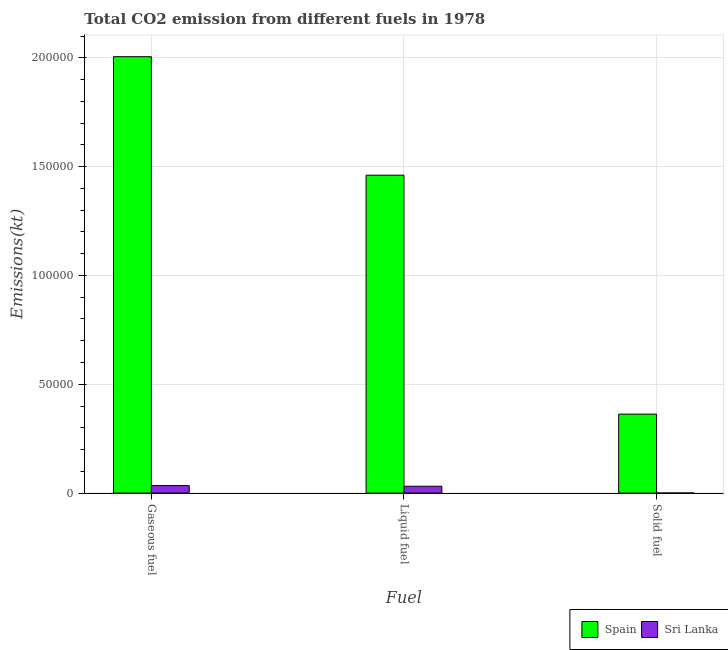Are the number of bars per tick equal to the number of legend labels?
Offer a very short reply. Yes. Are the number of bars on each tick of the X-axis equal?
Provide a succinct answer. Yes. How many bars are there on the 3rd tick from the left?
Provide a short and direct response. 2. What is the label of the 2nd group of bars from the left?
Your response must be concise. Liquid fuel. What is the amount of co2 emissions from solid fuel in Spain?
Offer a very short reply. 3.63e+04. Across all countries, what is the maximum amount of co2 emissions from gaseous fuel?
Offer a very short reply. 2.00e+05. Across all countries, what is the minimum amount of co2 emissions from solid fuel?
Keep it short and to the point. 29.34. In which country was the amount of co2 emissions from solid fuel minimum?
Your response must be concise. Sri Lanka. What is the total amount of co2 emissions from solid fuel in the graph?
Ensure brevity in your answer.  3.63e+04. What is the difference between the amount of co2 emissions from solid fuel in Sri Lanka and that in Spain?
Your response must be concise. -3.62e+04. What is the difference between the amount of co2 emissions from solid fuel in Spain and the amount of co2 emissions from gaseous fuel in Sri Lanka?
Keep it short and to the point. 3.28e+04. What is the average amount of co2 emissions from solid fuel per country?
Your response must be concise. 1.81e+04. What is the difference between the amount of co2 emissions from solid fuel and amount of co2 emissions from liquid fuel in Spain?
Make the answer very short. -1.10e+05. In how many countries, is the amount of co2 emissions from solid fuel greater than 40000 kt?
Keep it short and to the point. 0. What is the ratio of the amount of co2 emissions from liquid fuel in Sri Lanka to that in Spain?
Provide a short and direct response. 0.02. Is the amount of co2 emissions from gaseous fuel in Sri Lanka less than that in Spain?
Your answer should be compact. Yes. Is the difference between the amount of co2 emissions from solid fuel in Spain and Sri Lanka greater than the difference between the amount of co2 emissions from gaseous fuel in Spain and Sri Lanka?
Offer a very short reply. No. What is the difference between the highest and the second highest amount of co2 emissions from liquid fuel?
Offer a terse response. 1.43e+05. What is the difference between the highest and the lowest amount of co2 emissions from solid fuel?
Keep it short and to the point. 3.62e+04. In how many countries, is the amount of co2 emissions from solid fuel greater than the average amount of co2 emissions from solid fuel taken over all countries?
Your answer should be compact. 1. What does the 2nd bar from the left in Liquid fuel represents?
Keep it short and to the point. Sri Lanka. Is it the case that in every country, the sum of the amount of co2 emissions from gaseous fuel and amount of co2 emissions from liquid fuel is greater than the amount of co2 emissions from solid fuel?
Ensure brevity in your answer.  Yes. Does the graph contain any zero values?
Keep it short and to the point. No. How are the legend labels stacked?
Your answer should be very brief. Horizontal. What is the title of the graph?
Keep it short and to the point. Total CO2 emission from different fuels in 1978. Does "Sao Tome and Principe" appear as one of the legend labels in the graph?
Your answer should be very brief. No. What is the label or title of the X-axis?
Give a very brief answer. Fuel. What is the label or title of the Y-axis?
Provide a succinct answer. Emissions(kt). What is the Emissions(kt) of Spain in Gaseous fuel?
Your response must be concise. 2.00e+05. What is the Emissions(kt) of Sri Lanka in Gaseous fuel?
Keep it short and to the point. 3450.65. What is the Emissions(kt) in Spain in Liquid fuel?
Offer a very short reply. 1.46e+05. What is the Emissions(kt) of Sri Lanka in Liquid fuel?
Your answer should be compact. 3135.28. What is the Emissions(kt) of Spain in Solid fuel?
Offer a terse response. 3.63e+04. What is the Emissions(kt) in Sri Lanka in Solid fuel?
Your answer should be very brief. 29.34. Across all Fuel, what is the maximum Emissions(kt) in Spain?
Your answer should be compact. 2.00e+05. Across all Fuel, what is the maximum Emissions(kt) of Sri Lanka?
Ensure brevity in your answer.  3450.65. Across all Fuel, what is the minimum Emissions(kt) in Spain?
Make the answer very short. 3.63e+04. Across all Fuel, what is the minimum Emissions(kt) of Sri Lanka?
Ensure brevity in your answer.  29.34. What is the total Emissions(kt) in Spain in the graph?
Offer a very short reply. 3.83e+05. What is the total Emissions(kt) of Sri Lanka in the graph?
Give a very brief answer. 6615.27. What is the difference between the Emissions(kt) in Spain in Gaseous fuel and that in Liquid fuel?
Provide a succinct answer. 5.44e+04. What is the difference between the Emissions(kt) in Sri Lanka in Gaseous fuel and that in Liquid fuel?
Keep it short and to the point. 315.36. What is the difference between the Emissions(kt) of Spain in Gaseous fuel and that in Solid fuel?
Your response must be concise. 1.64e+05. What is the difference between the Emissions(kt) in Sri Lanka in Gaseous fuel and that in Solid fuel?
Your response must be concise. 3421.31. What is the difference between the Emissions(kt) in Spain in Liquid fuel and that in Solid fuel?
Offer a very short reply. 1.10e+05. What is the difference between the Emissions(kt) of Sri Lanka in Liquid fuel and that in Solid fuel?
Give a very brief answer. 3105.95. What is the difference between the Emissions(kt) in Spain in Gaseous fuel and the Emissions(kt) in Sri Lanka in Liquid fuel?
Provide a succinct answer. 1.97e+05. What is the difference between the Emissions(kt) in Spain in Gaseous fuel and the Emissions(kt) in Sri Lanka in Solid fuel?
Make the answer very short. 2.00e+05. What is the difference between the Emissions(kt) in Spain in Liquid fuel and the Emissions(kt) in Sri Lanka in Solid fuel?
Your response must be concise. 1.46e+05. What is the average Emissions(kt) of Spain per Fuel?
Offer a terse response. 1.28e+05. What is the average Emissions(kt) in Sri Lanka per Fuel?
Offer a very short reply. 2205.09. What is the difference between the Emissions(kt) in Spain and Emissions(kt) in Sri Lanka in Gaseous fuel?
Provide a short and direct response. 1.97e+05. What is the difference between the Emissions(kt) of Spain and Emissions(kt) of Sri Lanka in Liquid fuel?
Provide a short and direct response. 1.43e+05. What is the difference between the Emissions(kt) of Spain and Emissions(kt) of Sri Lanka in Solid fuel?
Provide a short and direct response. 3.62e+04. What is the ratio of the Emissions(kt) in Spain in Gaseous fuel to that in Liquid fuel?
Your answer should be compact. 1.37. What is the ratio of the Emissions(kt) of Sri Lanka in Gaseous fuel to that in Liquid fuel?
Keep it short and to the point. 1.1. What is the ratio of the Emissions(kt) in Spain in Gaseous fuel to that in Solid fuel?
Give a very brief answer. 5.53. What is the ratio of the Emissions(kt) of Sri Lanka in Gaseous fuel to that in Solid fuel?
Your response must be concise. 117.62. What is the ratio of the Emissions(kt) in Spain in Liquid fuel to that in Solid fuel?
Give a very brief answer. 4.03. What is the ratio of the Emissions(kt) of Sri Lanka in Liquid fuel to that in Solid fuel?
Give a very brief answer. 106.88. What is the difference between the highest and the second highest Emissions(kt) in Spain?
Your answer should be very brief. 5.44e+04. What is the difference between the highest and the second highest Emissions(kt) of Sri Lanka?
Ensure brevity in your answer.  315.36. What is the difference between the highest and the lowest Emissions(kt) of Spain?
Provide a short and direct response. 1.64e+05. What is the difference between the highest and the lowest Emissions(kt) of Sri Lanka?
Your answer should be very brief. 3421.31. 